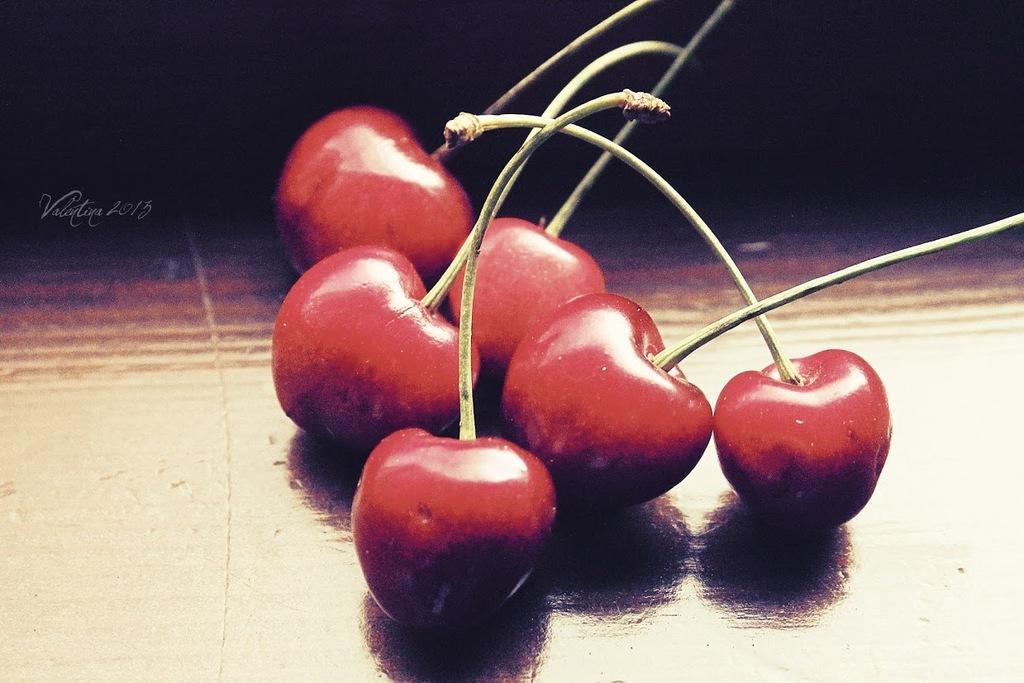Please provide a concise description of this image. In the center of the picture there are cherries placed on a table. The background is dark. 